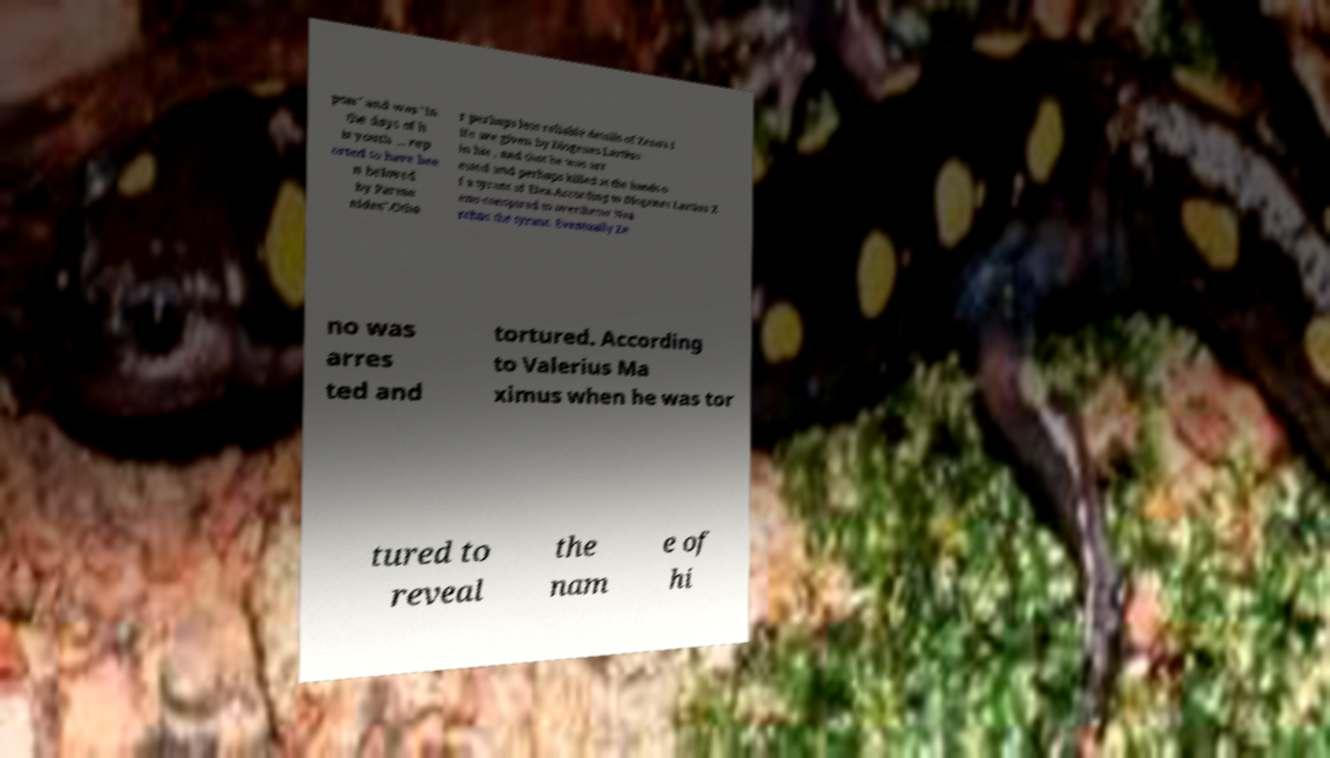Could you assist in decoding the text presented in this image and type it out clearly? pon" and was "in the days of h is youth … rep orted to have bee n beloved by Parme nides".Othe r perhaps less reliable details of Zeno's l ife are given by Diogenes Lartius in his , and that he was arr ested and perhaps killed at the hands o f a tyrant of Elea.According to Diogenes Lartius Z eno conspired to overthrow Nea rchus the tyrant. Eventually Ze no was arres ted and tortured. According to Valerius Ma ximus when he was tor tured to reveal the nam e of hi 